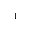Convert formula to latex. <formula><loc_0><loc_0><loc_500><loc_500>^ { - 1 }</formula> 